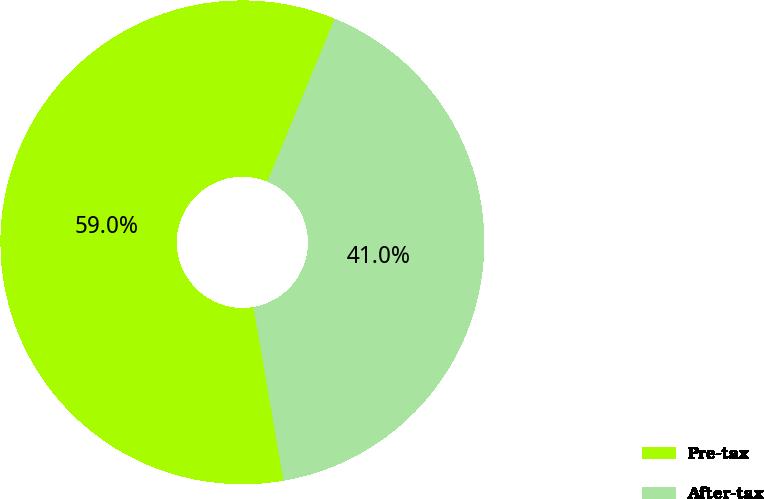<chart> <loc_0><loc_0><loc_500><loc_500><pie_chart><fcel>Pre-tax<fcel>After-tax<nl><fcel>58.96%<fcel>41.04%<nl></chart> 